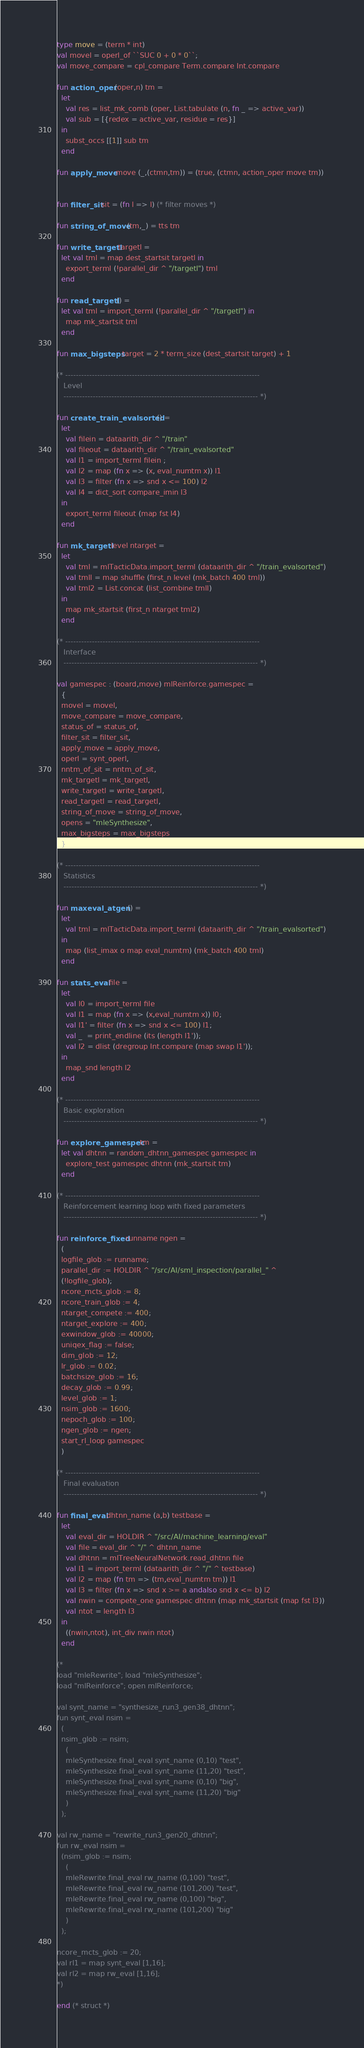Convert code to text. <code><loc_0><loc_0><loc_500><loc_500><_SML_>type move = (term * int)
val movel = operl_of ``SUC 0 + 0 * 0``;
val move_compare = cpl_compare Term.compare Int.compare

fun action_oper (oper,n) tm =
  let
    val res = list_mk_comb (oper, List.tabulate (n, fn _ => active_var))
    val sub = [{redex = active_var, residue = res}]
  in
    subst_occs [[1]] sub tm
  end

fun apply_move move (_,(ctmn,tm)) = (true, (ctmn, action_oper move tm))


fun filter_sit sit = (fn l => l) (* filter moves *)

fun string_of_move (tm,_) = tts tm

fun write_targetl targetl =
  let val tml = map dest_startsit targetl in
    export_terml (!parallel_dir ^ "/targetl") tml
  end

fun read_targetl () =
  let val tml = import_terml (!parallel_dir ^ "/targetl") in
    map mk_startsit tml
  end

fun max_bigsteps target = 2 * term_size (dest_startsit target) + 1

(* -------------------------------------------------------------------------
   Level
   ------------------------------------------------------------------------- *)

fun create_train_evalsorted () =
  let
    val filein = dataarith_dir ^ "/train"
    val fileout = dataarith_dir ^ "/train_evalsorted"
    val l1 = import_terml filein ;
    val l2 = map (fn x => (x, eval_numtm x)) l1
    val l3 = filter (fn x => snd x <= 100) l2
    val l4 = dict_sort compare_imin l3
  in
    export_terml fileout (map fst l4)
  end

fun mk_targetl level ntarget =
  let
    val tml = mlTacticData.import_terml (dataarith_dir ^ "/train_evalsorted")
    val tmll = map shuffle (first_n level (mk_batch 400 tml))
    val tml2 = List.concat (list_combine tmll)
  in
    map mk_startsit (first_n ntarget tml2)
  end

(* -------------------------------------------------------------------------
   Interface
   ------------------------------------------------------------------------- *)

val gamespec : (board,move) mlReinforce.gamespec =
  {
  movel = movel,
  move_compare = move_compare,
  status_of = status_of,
  filter_sit = filter_sit,
  apply_move = apply_move,
  operl = synt_operl,
  nntm_of_sit = nntm_of_sit,
  mk_targetl = mk_targetl,
  write_targetl = write_targetl,
  read_targetl = read_targetl,
  string_of_move = string_of_move,
  opens = "mleSynthesize",
  max_bigsteps = max_bigsteps
  }

(* -------------------------------------------------------------------------
   Statistics
   ------------------------------------------------------------------------- *)

fun maxeval_atgen () =
  let
    val tml = mlTacticData.import_terml (dataarith_dir ^ "/train_evalsorted")
  in
    map (list_imax o map eval_numtm) (mk_batch 400 tml)
  end

fun stats_eval file =
  let
    val l0 = import_terml file
    val l1 = map (fn x => (x,eval_numtm x)) l0;
    val l1' = filter (fn x => snd x <= 100) l1;
    val _  = print_endline (its (length l1'));
    val l2 = dlist (dregroup Int.compare (map swap l1'));
  in
    map_snd length l2
  end

(* -------------------------------------------------------------------------
   Basic exploration
   ------------------------------------------------------------------------- *)

fun explore_gamespec tm =
  let val dhtnn = random_dhtnn_gamespec gamespec in
    explore_test gamespec dhtnn (mk_startsit tm)
  end

(* -------------------------------------------------------------------------
   Reinforcement learning loop with fixed parameters
   ------------------------------------------------------------------------- *)

fun reinforce_fixed runname ngen =
  (
  logfile_glob := runname;
  parallel_dir := HOLDIR ^ "/src/AI/sml_inspection/parallel_" ^
  (!logfile_glob);
  ncore_mcts_glob := 8;
  ncore_train_glob := 4;
  ntarget_compete := 400;
  ntarget_explore := 400;
  exwindow_glob := 40000;
  uniqex_flag := false;
  dim_glob := 12;
  lr_glob := 0.02;
  batchsize_glob := 16;
  decay_glob := 0.99;
  level_glob := 1;
  nsim_glob := 1600;
  nepoch_glob := 100;
  ngen_glob := ngen;
  start_rl_loop gamespec
  )

(* -------------------------------------------------------------------------
   Final evaluation
   ------------------------------------------------------------------------- *)

fun final_eval dhtnn_name (a,b) testbase =
  let
    val eval_dir = HOLDIR ^ "/src/AI/machine_learning/eval"
    val file = eval_dir ^ "/" ^ dhtnn_name
    val dhtnn = mlTreeNeuralNetwork.read_dhtnn file
    val l1 = import_terml (dataarith_dir ^ "/" ^ testbase)
    val l2 = map (fn tm => (tm,eval_numtm tm)) l1
    val l3 = filter (fn x => snd x >= a andalso snd x <= b) l2
    val nwin = compete_one gamespec dhtnn (map mk_startsit (map fst l3))
    val ntot = length l3
  in
    ((nwin,ntot), int_div nwin ntot)
  end

(*
load "mleRewrite"; load "mleSynthesize";
load "mlReinforce"; open mlReinforce;

val synt_name = "synthesize_run3_gen38_dhtnn";
fun synt_eval nsim =
  (
  nsim_glob := nsim;
    (
    mleSynthesize.final_eval synt_name (0,10) "test",
    mleSynthesize.final_eval synt_name (11,20) "test",
    mleSynthesize.final_eval synt_name (0,10) "big",
    mleSynthesize.final_eval synt_name (11,20) "big"
    )
  );

val rw_name = "rewrite_run3_gen20_dhtnn";
fun rw_eval nsim =
  (nsim_glob := nsim;
    (
    mleRewrite.final_eval rw_name (0,100) "test",
    mleRewrite.final_eval rw_name (101,200) "test",
    mleRewrite.final_eval rw_name (0,100) "big",
    mleRewrite.final_eval rw_name (101,200) "big"
    )
  );

ncore_mcts_glob := 20;
val rl1 = map synt_eval [1,16];
val rl2 = map rw_eval [1,16];
*)

end (* struct *)
</code> 